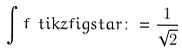Convert formula to latex. <formula><loc_0><loc_0><loc_500><loc_500>\int f { \ t i k z f i g { s t a r } } \colon = \frac { 1 } { \sqrt { 2 } }</formula> 